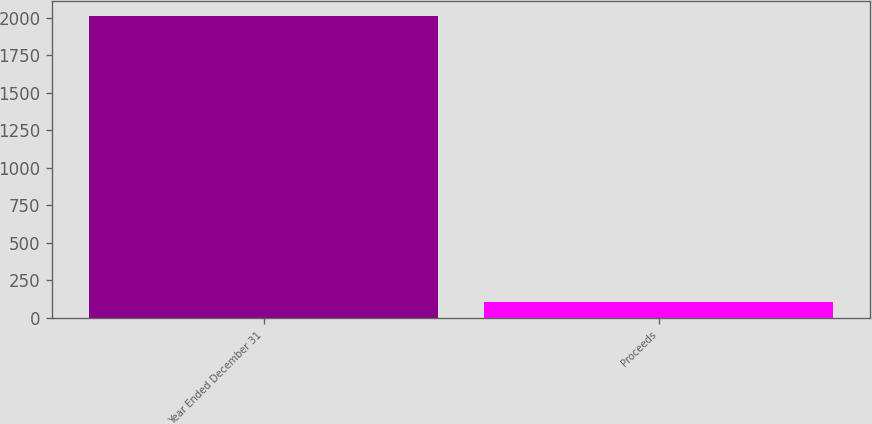Convert chart. <chart><loc_0><loc_0><loc_500><loc_500><bar_chart><fcel>Year Ended December 31<fcel>Proceeds<nl><fcel>2009<fcel>107<nl></chart> 